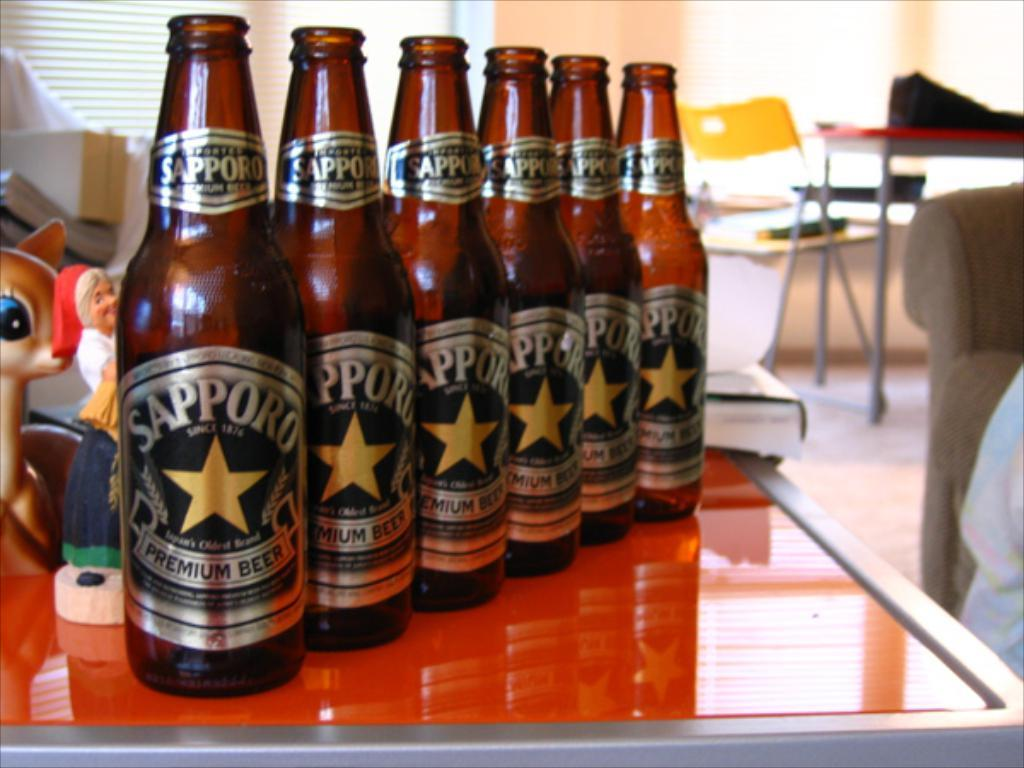<image>
Describe the image concisely. Six Sapporo Premium beers lined up on a table. 